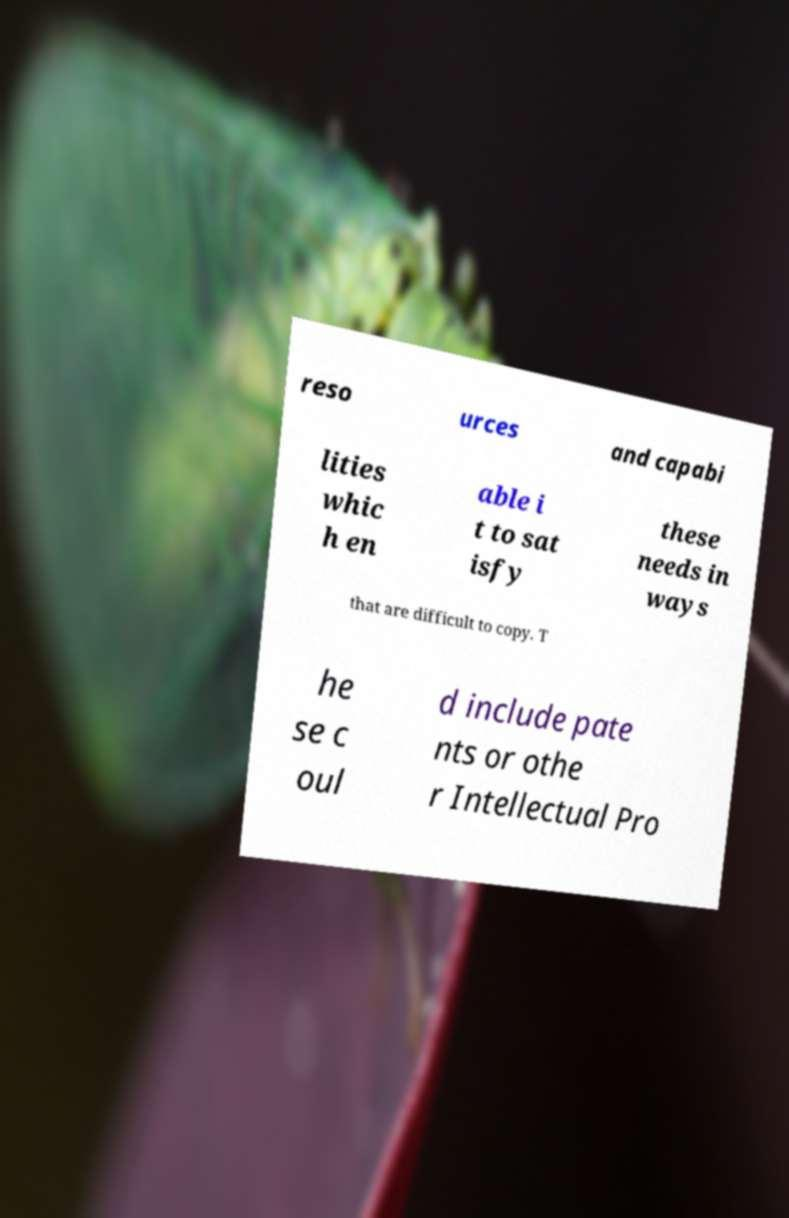Please read and relay the text visible in this image. What does it say? reso urces and capabi lities whic h en able i t to sat isfy these needs in ways that are difficult to copy. T he se c oul d include pate nts or othe r Intellectual Pro 